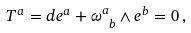Convert formula to latex. <formula><loc_0><loc_0><loc_500><loc_500>T ^ { a } = d e ^ { a } + \omega ^ { a } _ { \ b } \wedge e ^ { b } = 0 \, ,</formula> 